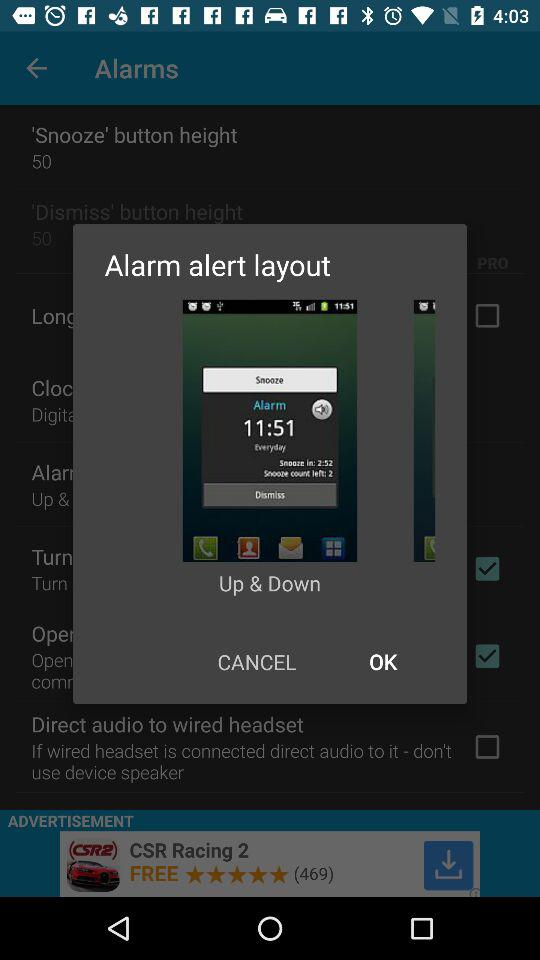What is the alarm time? The alarm time is 11:51. 